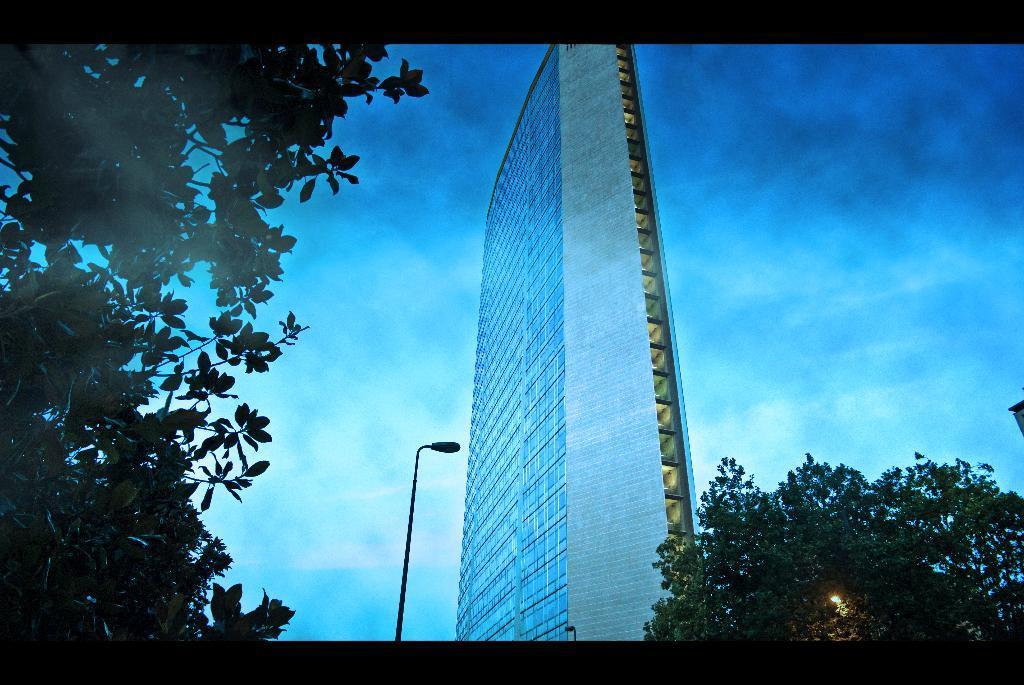Could you give a brief overview of what you see in this image? In this image we can see the building with windows, street lights, trees, we can see the sky with clouds. 